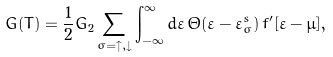Convert formula to latex. <formula><loc_0><loc_0><loc_500><loc_500>G ( T ) = \frac { 1 } { 2 } G _ { 2 } \sum _ { \sigma = \uparrow , \downarrow } \int _ { - \infty } ^ { \infty } d \varepsilon \, \Theta ( \varepsilon - \varepsilon ^ { s } _ { \sigma } ) \, f ^ { \prime } [ \varepsilon - \mu ] ,</formula> 